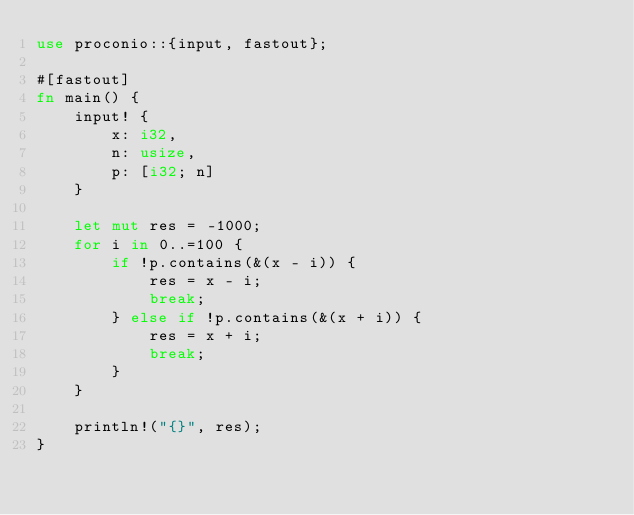<code> <loc_0><loc_0><loc_500><loc_500><_Rust_>use proconio::{input, fastout};

#[fastout]
fn main() {
    input! {
        x: i32,
        n: usize,
        p: [i32; n]
    }

    let mut res = -1000;
    for i in 0..=100 {
        if !p.contains(&(x - i)) {
            res = x - i;
            break;
        } else if !p.contains(&(x + i)) {
            res = x + i;
            break;
        }
    }

    println!("{}", res);
}
</code> 